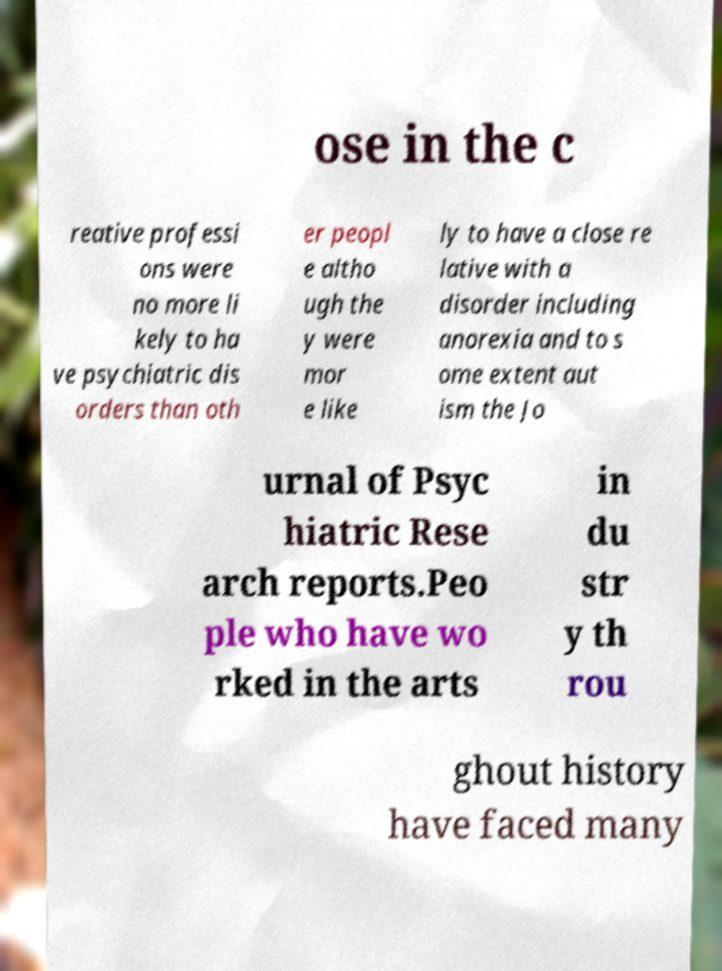Can you accurately transcribe the text from the provided image for me? ose in the c reative professi ons were no more li kely to ha ve psychiatric dis orders than oth er peopl e altho ugh the y were mor e like ly to have a close re lative with a disorder including anorexia and to s ome extent aut ism the Jo urnal of Psyc hiatric Rese arch reports.Peo ple who have wo rked in the arts in du str y th rou ghout history have faced many 